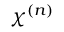<formula> <loc_0><loc_0><loc_500><loc_500>\chi ^ { ( n ) }</formula> 